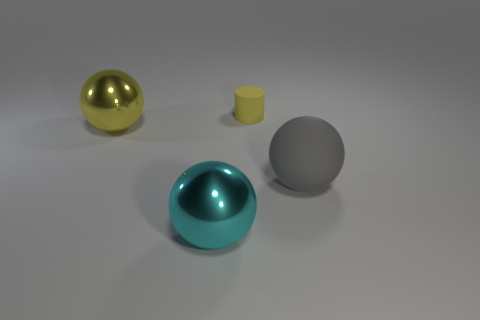The cylinder is what size?
Keep it short and to the point. Small. Is there any other thing that has the same size as the cylinder?
Ensure brevity in your answer.  No. Are there any yellow metallic balls of the same size as the cyan sphere?
Offer a terse response. Yes. Do the yellow thing that is on the left side of the cyan ball and the big gray thing have the same shape?
Keep it short and to the point. Yes. There is a big object on the right side of the big cyan object; what is its material?
Offer a very short reply. Rubber. The big shiny object that is left of the big cyan thing left of the cylinder is what shape?
Offer a terse response. Sphere. There is a yellow shiny object; is its shape the same as the object to the right of the cylinder?
Offer a very short reply. Yes. There is a large thing in front of the gray rubber ball; what number of matte cylinders are in front of it?
Your answer should be compact. 0. There is a large cyan thing that is the same shape as the gray object; what material is it?
Provide a short and direct response. Metal. What number of cyan objects are small rubber objects or big shiny spheres?
Your answer should be very brief. 1. 